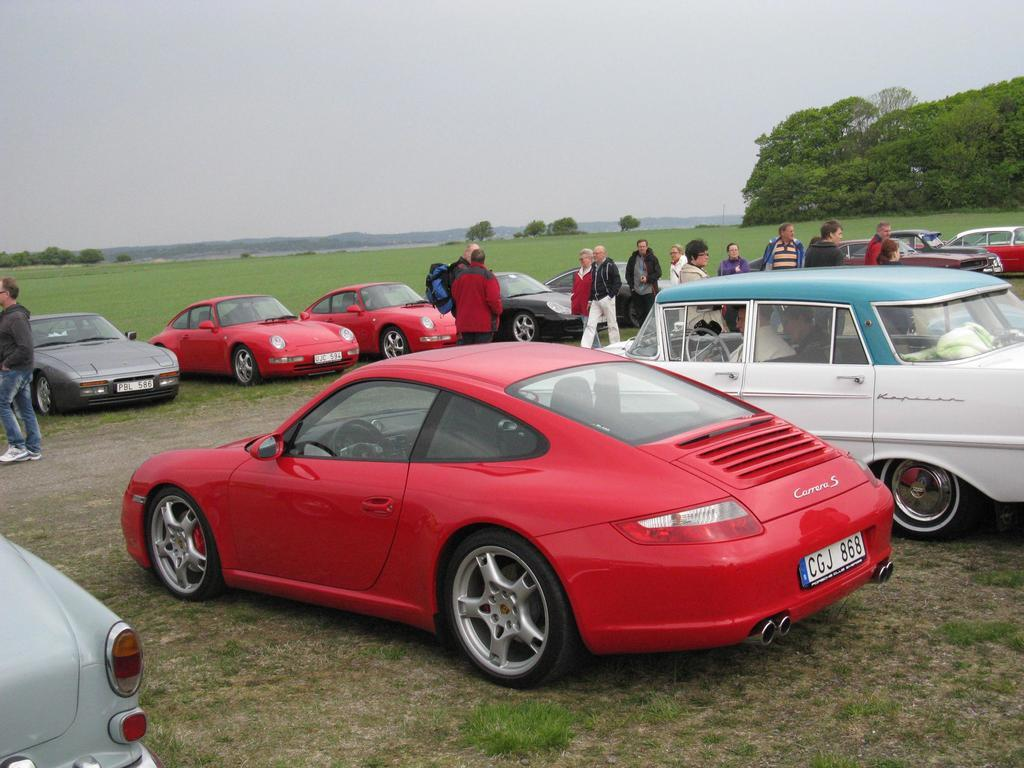What is the main subject of the image? The main subject of the image is many cars. What else can be seen in the image besides cars? There are many people, hills, grassy land, and the sky visible in the image. What type of pump can be seen in the image? There is no pump present in the image. How does the whip affect the people in the image? There is no whip present in the image, so it cannot affect the people. 